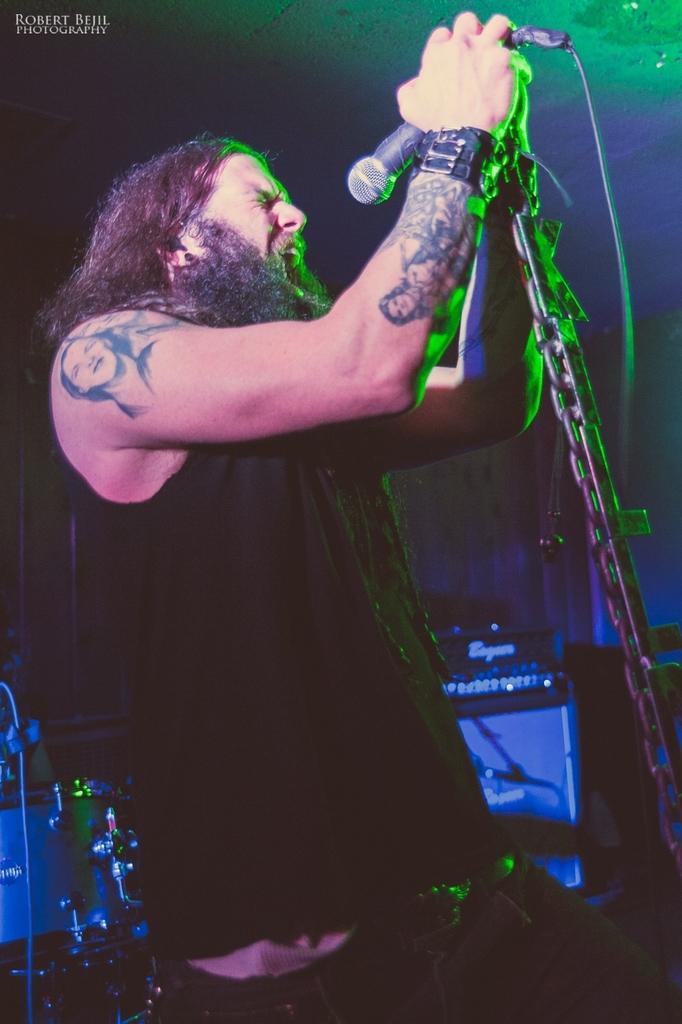Please provide a concise description of this image. In this image I can see a man is standing and I can see he is holding a mic. I can also see he is wearing black dress and I can see this image is little bit in dark from background. 